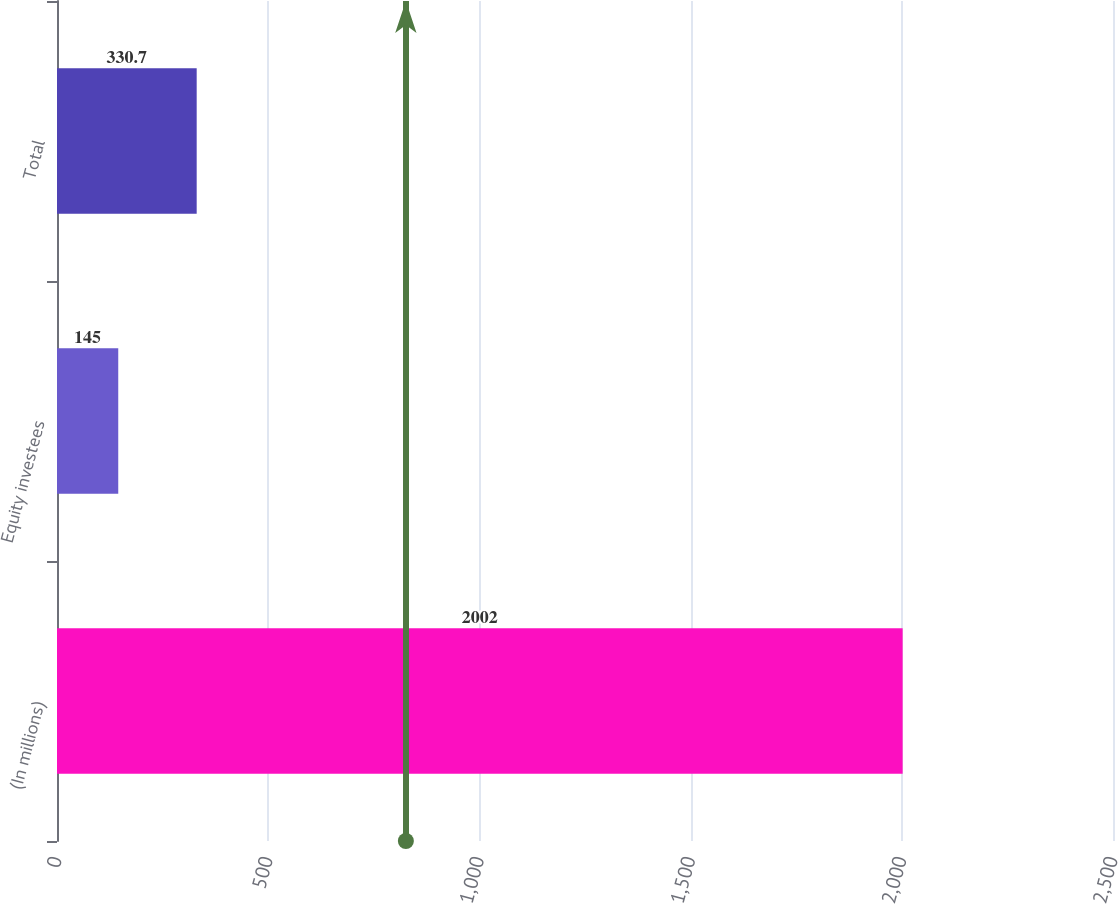<chart> <loc_0><loc_0><loc_500><loc_500><bar_chart><fcel>(In millions)<fcel>Equity investees<fcel>Total<nl><fcel>2002<fcel>145<fcel>330.7<nl></chart> 